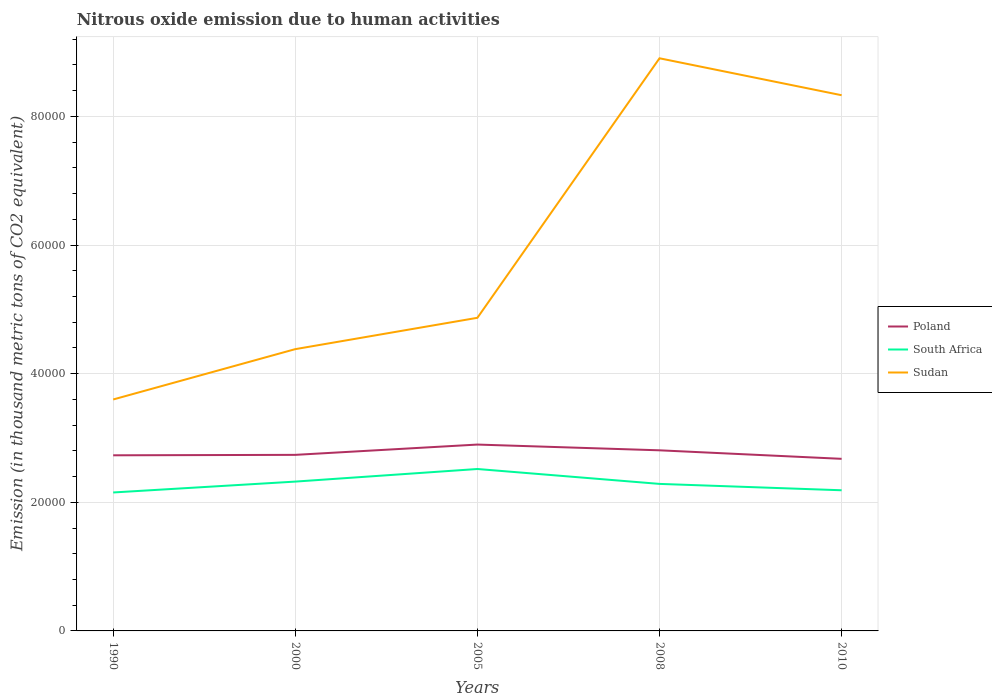Does the line corresponding to Sudan intersect with the line corresponding to South Africa?
Provide a short and direct response. No. Across all years, what is the maximum amount of nitrous oxide emitted in South Africa?
Provide a short and direct response. 2.15e+04. In which year was the amount of nitrous oxide emitted in South Africa maximum?
Keep it short and to the point. 1990. What is the total amount of nitrous oxide emitted in Sudan in the graph?
Your response must be concise. -3.95e+04. What is the difference between the highest and the second highest amount of nitrous oxide emitted in Sudan?
Ensure brevity in your answer.  5.31e+04. Is the amount of nitrous oxide emitted in Sudan strictly greater than the amount of nitrous oxide emitted in South Africa over the years?
Offer a terse response. No. How many years are there in the graph?
Offer a very short reply. 5. Are the values on the major ticks of Y-axis written in scientific E-notation?
Keep it short and to the point. No. Does the graph contain any zero values?
Keep it short and to the point. No. How many legend labels are there?
Your answer should be very brief. 3. How are the legend labels stacked?
Keep it short and to the point. Vertical. What is the title of the graph?
Provide a succinct answer. Nitrous oxide emission due to human activities. Does "Costa Rica" appear as one of the legend labels in the graph?
Provide a short and direct response. No. What is the label or title of the X-axis?
Offer a very short reply. Years. What is the label or title of the Y-axis?
Your answer should be compact. Emission (in thousand metric tons of CO2 equivalent). What is the Emission (in thousand metric tons of CO2 equivalent) in Poland in 1990?
Give a very brief answer. 2.73e+04. What is the Emission (in thousand metric tons of CO2 equivalent) of South Africa in 1990?
Your answer should be compact. 2.15e+04. What is the Emission (in thousand metric tons of CO2 equivalent) of Sudan in 1990?
Provide a succinct answer. 3.60e+04. What is the Emission (in thousand metric tons of CO2 equivalent) of Poland in 2000?
Give a very brief answer. 2.74e+04. What is the Emission (in thousand metric tons of CO2 equivalent) of South Africa in 2000?
Your answer should be compact. 2.32e+04. What is the Emission (in thousand metric tons of CO2 equivalent) in Sudan in 2000?
Keep it short and to the point. 4.38e+04. What is the Emission (in thousand metric tons of CO2 equivalent) of Poland in 2005?
Provide a short and direct response. 2.90e+04. What is the Emission (in thousand metric tons of CO2 equivalent) in South Africa in 2005?
Provide a succinct answer. 2.52e+04. What is the Emission (in thousand metric tons of CO2 equivalent) of Sudan in 2005?
Make the answer very short. 4.87e+04. What is the Emission (in thousand metric tons of CO2 equivalent) of Poland in 2008?
Your answer should be compact. 2.81e+04. What is the Emission (in thousand metric tons of CO2 equivalent) of South Africa in 2008?
Give a very brief answer. 2.29e+04. What is the Emission (in thousand metric tons of CO2 equivalent) of Sudan in 2008?
Ensure brevity in your answer.  8.90e+04. What is the Emission (in thousand metric tons of CO2 equivalent) of Poland in 2010?
Your response must be concise. 2.68e+04. What is the Emission (in thousand metric tons of CO2 equivalent) of South Africa in 2010?
Give a very brief answer. 2.19e+04. What is the Emission (in thousand metric tons of CO2 equivalent) in Sudan in 2010?
Keep it short and to the point. 8.33e+04. Across all years, what is the maximum Emission (in thousand metric tons of CO2 equivalent) of Poland?
Make the answer very short. 2.90e+04. Across all years, what is the maximum Emission (in thousand metric tons of CO2 equivalent) in South Africa?
Provide a succinct answer. 2.52e+04. Across all years, what is the maximum Emission (in thousand metric tons of CO2 equivalent) in Sudan?
Offer a terse response. 8.90e+04. Across all years, what is the minimum Emission (in thousand metric tons of CO2 equivalent) of Poland?
Provide a succinct answer. 2.68e+04. Across all years, what is the minimum Emission (in thousand metric tons of CO2 equivalent) in South Africa?
Give a very brief answer. 2.15e+04. Across all years, what is the minimum Emission (in thousand metric tons of CO2 equivalent) in Sudan?
Offer a very short reply. 3.60e+04. What is the total Emission (in thousand metric tons of CO2 equivalent) in Poland in the graph?
Keep it short and to the point. 1.38e+05. What is the total Emission (in thousand metric tons of CO2 equivalent) of South Africa in the graph?
Offer a terse response. 1.15e+05. What is the total Emission (in thousand metric tons of CO2 equivalent) in Sudan in the graph?
Keep it short and to the point. 3.01e+05. What is the difference between the Emission (in thousand metric tons of CO2 equivalent) in Poland in 1990 and that in 2000?
Provide a short and direct response. -66.8. What is the difference between the Emission (in thousand metric tons of CO2 equivalent) of South Africa in 1990 and that in 2000?
Ensure brevity in your answer.  -1690.3. What is the difference between the Emission (in thousand metric tons of CO2 equivalent) in Sudan in 1990 and that in 2000?
Provide a short and direct response. -7827.3. What is the difference between the Emission (in thousand metric tons of CO2 equivalent) in Poland in 1990 and that in 2005?
Offer a terse response. -1667.4. What is the difference between the Emission (in thousand metric tons of CO2 equivalent) of South Africa in 1990 and that in 2005?
Your answer should be very brief. -3649.4. What is the difference between the Emission (in thousand metric tons of CO2 equivalent) in Sudan in 1990 and that in 2005?
Offer a very short reply. -1.27e+04. What is the difference between the Emission (in thousand metric tons of CO2 equivalent) of Poland in 1990 and that in 2008?
Your answer should be very brief. -773.9. What is the difference between the Emission (in thousand metric tons of CO2 equivalent) in South Africa in 1990 and that in 2008?
Your answer should be compact. -1332.8. What is the difference between the Emission (in thousand metric tons of CO2 equivalent) in Sudan in 1990 and that in 2008?
Your response must be concise. -5.31e+04. What is the difference between the Emission (in thousand metric tons of CO2 equivalent) of Poland in 1990 and that in 2010?
Offer a very short reply. 550.6. What is the difference between the Emission (in thousand metric tons of CO2 equivalent) of South Africa in 1990 and that in 2010?
Your answer should be very brief. -343.1. What is the difference between the Emission (in thousand metric tons of CO2 equivalent) of Sudan in 1990 and that in 2010?
Give a very brief answer. -4.73e+04. What is the difference between the Emission (in thousand metric tons of CO2 equivalent) in Poland in 2000 and that in 2005?
Your answer should be very brief. -1600.6. What is the difference between the Emission (in thousand metric tons of CO2 equivalent) in South Africa in 2000 and that in 2005?
Your response must be concise. -1959.1. What is the difference between the Emission (in thousand metric tons of CO2 equivalent) in Sudan in 2000 and that in 2005?
Offer a very short reply. -4871.9. What is the difference between the Emission (in thousand metric tons of CO2 equivalent) of Poland in 2000 and that in 2008?
Your answer should be very brief. -707.1. What is the difference between the Emission (in thousand metric tons of CO2 equivalent) in South Africa in 2000 and that in 2008?
Provide a short and direct response. 357.5. What is the difference between the Emission (in thousand metric tons of CO2 equivalent) in Sudan in 2000 and that in 2008?
Offer a very short reply. -4.52e+04. What is the difference between the Emission (in thousand metric tons of CO2 equivalent) of Poland in 2000 and that in 2010?
Give a very brief answer. 617.4. What is the difference between the Emission (in thousand metric tons of CO2 equivalent) of South Africa in 2000 and that in 2010?
Provide a succinct answer. 1347.2. What is the difference between the Emission (in thousand metric tons of CO2 equivalent) of Sudan in 2000 and that in 2010?
Offer a terse response. -3.95e+04. What is the difference between the Emission (in thousand metric tons of CO2 equivalent) of Poland in 2005 and that in 2008?
Offer a very short reply. 893.5. What is the difference between the Emission (in thousand metric tons of CO2 equivalent) of South Africa in 2005 and that in 2008?
Provide a succinct answer. 2316.6. What is the difference between the Emission (in thousand metric tons of CO2 equivalent) of Sudan in 2005 and that in 2008?
Provide a short and direct response. -4.04e+04. What is the difference between the Emission (in thousand metric tons of CO2 equivalent) of Poland in 2005 and that in 2010?
Your answer should be very brief. 2218. What is the difference between the Emission (in thousand metric tons of CO2 equivalent) in South Africa in 2005 and that in 2010?
Keep it short and to the point. 3306.3. What is the difference between the Emission (in thousand metric tons of CO2 equivalent) of Sudan in 2005 and that in 2010?
Ensure brevity in your answer.  -3.46e+04. What is the difference between the Emission (in thousand metric tons of CO2 equivalent) in Poland in 2008 and that in 2010?
Offer a terse response. 1324.5. What is the difference between the Emission (in thousand metric tons of CO2 equivalent) in South Africa in 2008 and that in 2010?
Offer a very short reply. 989.7. What is the difference between the Emission (in thousand metric tons of CO2 equivalent) in Sudan in 2008 and that in 2010?
Offer a very short reply. 5743.3. What is the difference between the Emission (in thousand metric tons of CO2 equivalent) of Poland in 1990 and the Emission (in thousand metric tons of CO2 equivalent) of South Africa in 2000?
Make the answer very short. 4090.7. What is the difference between the Emission (in thousand metric tons of CO2 equivalent) of Poland in 1990 and the Emission (in thousand metric tons of CO2 equivalent) of Sudan in 2000?
Offer a very short reply. -1.65e+04. What is the difference between the Emission (in thousand metric tons of CO2 equivalent) in South Africa in 1990 and the Emission (in thousand metric tons of CO2 equivalent) in Sudan in 2000?
Your response must be concise. -2.23e+04. What is the difference between the Emission (in thousand metric tons of CO2 equivalent) in Poland in 1990 and the Emission (in thousand metric tons of CO2 equivalent) in South Africa in 2005?
Offer a terse response. 2131.6. What is the difference between the Emission (in thousand metric tons of CO2 equivalent) in Poland in 1990 and the Emission (in thousand metric tons of CO2 equivalent) in Sudan in 2005?
Your response must be concise. -2.14e+04. What is the difference between the Emission (in thousand metric tons of CO2 equivalent) in South Africa in 1990 and the Emission (in thousand metric tons of CO2 equivalent) in Sudan in 2005?
Ensure brevity in your answer.  -2.72e+04. What is the difference between the Emission (in thousand metric tons of CO2 equivalent) in Poland in 1990 and the Emission (in thousand metric tons of CO2 equivalent) in South Africa in 2008?
Provide a short and direct response. 4448.2. What is the difference between the Emission (in thousand metric tons of CO2 equivalent) in Poland in 1990 and the Emission (in thousand metric tons of CO2 equivalent) in Sudan in 2008?
Provide a succinct answer. -6.17e+04. What is the difference between the Emission (in thousand metric tons of CO2 equivalent) in South Africa in 1990 and the Emission (in thousand metric tons of CO2 equivalent) in Sudan in 2008?
Offer a very short reply. -6.75e+04. What is the difference between the Emission (in thousand metric tons of CO2 equivalent) of Poland in 1990 and the Emission (in thousand metric tons of CO2 equivalent) of South Africa in 2010?
Give a very brief answer. 5437.9. What is the difference between the Emission (in thousand metric tons of CO2 equivalent) in Poland in 1990 and the Emission (in thousand metric tons of CO2 equivalent) in Sudan in 2010?
Ensure brevity in your answer.  -5.60e+04. What is the difference between the Emission (in thousand metric tons of CO2 equivalent) of South Africa in 1990 and the Emission (in thousand metric tons of CO2 equivalent) of Sudan in 2010?
Provide a succinct answer. -6.18e+04. What is the difference between the Emission (in thousand metric tons of CO2 equivalent) of Poland in 2000 and the Emission (in thousand metric tons of CO2 equivalent) of South Africa in 2005?
Offer a very short reply. 2198.4. What is the difference between the Emission (in thousand metric tons of CO2 equivalent) in Poland in 2000 and the Emission (in thousand metric tons of CO2 equivalent) in Sudan in 2005?
Offer a very short reply. -2.13e+04. What is the difference between the Emission (in thousand metric tons of CO2 equivalent) of South Africa in 2000 and the Emission (in thousand metric tons of CO2 equivalent) of Sudan in 2005?
Your response must be concise. -2.55e+04. What is the difference between the Emission (in thousand metric tons of CO2 equivalent) in Poland in 2000 and the Emission (in thousand metric tons of CO2 equivalent) in South Africa in 2008?
Offer a very short reply. 4515. What is the difference between the Emission (in thousand metric tons of CO2 equivalent) of Poland in 2000 and the Emission (in thousand metric tons of CO2 equivalent) of Sudan in 2008?
Offer a terse response. -6.17e+04. What is the difference between the Emission (in thousand metric tons of CO2 equivalent) of South Africa in 2000 and the Emission (in thousand metric tons of CO2 equivalent) of Sudan in 2008?
Offer a terse response. -6.58e+04. What is the difference between the Emission (in thousand metric tons of CO2 equivalent) of Poland in 2000 and the Emission (in thousand metric tons of CO2 equivalent) of South Africa in 2010?
Offer a terse response. 5504.7. What is the difference between the Emission (in thousand metric tons of CO2 equivalent) in Poland in 2000 and the Emission (in thousand metric tons of CO2 equivalent) in Sudan in 2010?
Provide a short and direct response. -5.59e+04. What is the difference between the Emission (in thousand metric tons of CO2 equivalent) in South Africa in 2000 and the Emission (in thousand metric tons of CO2 equivalent) in Sudan in 2010?
Provide a succinct answer. -6.01e+04. What is the difference between the Emission (in thousand metric tons of CO2 equivalent) of Poland in 2005 and the Emission (in thousand metric tons of CO2 equivalent) of South Africa in 2008?
Provide a succinct answer. 6115.6. What is the difference between the Emission (in thousand metric tons of CO2 equivalent) of Poland in 2005 and the Emission (in thousand metric tons of CO2 equivalent) of Sudan in 2008?
Keep it short and to the point. -6.01e+04. What is the difference between the Emission (in thousand metric tons of CO2 equivalent) of South Africa in 2005 and the Emission (in thousand metric tons of CO2 equivalent) of Sudan in 2008?
Provide a succinct answer. -6.39e+04. What is the difference between the Emission (in thousand metric tons of CO2 equivalent) in Poland in 2005 and the Emission (in thousand metric tons of CO2 equivalent) in South Africa in 2010?
Make the answer very short. 7105.3. What is the difference between the Emission (in thousand metric tons of CO2 equivalent) in Poland in 2005 and the Emission (in thousand metric tons of CO2 equivalent) in Sudan in 2010?
Provide a succinct answer. -5.43e+04. What is the difference between the Emission (in thousand metric tons of CO2 equivalent) of South Africa in 2005 and the Emission (in thousand metric tons of CO2 equivalent) of Sudan in 2010?
Make the answer very short. -5.81e+04. What is the difference between the Emission (in thousand metric tons of CO2 equivalent) of Poland in 2008 and the Emission (in thousand metric tons of CO2 equivalent) of South Africa in 2010?
Ensure brevity in your answer.  6211.8. What is the difference between the Emission (in thousand metric tons of CO2 equivalent) of Poland in 2008 and the Emission (in thousand metric tons of CO2 equivalent) of Sudan in 2010?
Ensure brevity in your answer.  -5.52e+04. What is the difference between the Emission (in thousand metric tons of CO2 equivalent) of South Africa in 2008 and the Emission (in thousand metric tons of CO2 equivalent) of Sudan in 2010?
Keep it short and to the point. -6.04e+04. What is the average Emission (in thousand metric tons of CO2 equivalent) in Poland per year?
Provide a succinct answer. 2.77e+04. What is the average Emission (in thousand metric tons of CO2 equivalent) in South Africa per year?
Your response must be concise. 2.29e+04. What is the average Emission (in thousand metric tons of CO2 equivalent) in Sudan per year?
Your answer should be compact. 6.02e+04. In the year 1990, what is the difference between the Emission (in thousand metric tons of CO2 equivalent) of Poland and Emission (in thousand metric tons of CO2 equivalent) of South Africa?
Offer a terse response. 5781. In the year 1990, what is the difference between the Emission (in thousand metric tons of CO2 equivalent) of Poland and Emission (in thousand metric tons of CO2 equivalent) of Sudan?
Keep it short and to the point. -8678. In the year 1990, what is the difference between the Emission (in thousand metric tons of CO2 equivalent) of South Africa and Emission (in thousand metric tons of CO2 equivalent) of Sudan?
Ensure brevity in your answer.  -1.45e+04. In the year 2000, what is the difference between the Emission (in thousand metric tons of CO2 equivalent) of Poland and Emission (in thousand metric tons of CO2 equivalent) of South Africa?
Your answer should be very brief. 4157.5. In the year 2000, what is the difference between the Emission (in thousand metric tons of CO2 equivalent) of Poland and Emission (in thousand metric tons of CO2 equivalent) of Sudan?
Give a very brief answer. -1.64e+04. In the year 2000, what is the difference between the Emission (in thousand metric tons of CO2 equivalent) of South Africa and Emission (in thousand metric tons of CO2 equivalent) of Sudan?
Your answer should be compact. -2.06e+04. In the year 2005, what is the difference between the Emission (in thousand metric tons of CO2 equivalent) in Poland and Emission (in thousand metric tons of CO2 equivalent) in South Africa?
Make the answer very short. 3799. In the year 2005, what is the difference between the Emission (in thousand metric tons of CO2 equivalent) in Poland and Emission (in thousand metric tons of CO2 equivalent) in Sudan?
Give a very brief answer. -1.97e+04. In the year 2005, what is the difference between the Emission (in thousand metric tons of CO2 equivalent) in South Africa and Emission (in thousand metric tons of CO2 equivalent) in Sudan?
Ensure brevity in your answer.  -2.35e+04. In the year 2008, what is the difference between the Emission (in thousand metric tons of CO2 equivalent) of Poland and Emission (in thousand metric tons of CO2 equivalent) of South Africa?
Give a very brief answer. 5222.1. In the year 2008, what is the difference between the Emission (in thousand metric tons of CO2 equivalent) in Poland and Emission (in thousand metric tons of CO2 equivalent) in Sudan?
Your answer should be compact. -6.10e+04. In the year 2008, what is the difference between the Emission (in thousand metric tons of CO2 equivalent) in South Africa and Emission (in thousand metric tons of CO2 equivalent) in Sudan?
Offer a terse response. -6.62e+04. In the year 2010, what is the difference between the Emission (in thousand metric tons of CO2 equivalent) in Poland and Emission (in thousand metric tons of CO2 equivalent) in South Africa?
Give a very brief answer. 4887.3. In the year 2010, what is the difference between the Emission (in thousand metric tons of CO2 equivalent) in Poland and Emission (in thousand metric tons of CO2 equivalent) in Sudan?
Your answer should be compact. -5.65e+04. In the year 2010, what is the difference between the Emission (in thousand metric tons of CO2 equivalent) in South Africa and Emission (in thousand metric tons of CO2 equivalent) in Sudan?
Provide a succinct answer. -6.14e+04. What is the ratio of the Emission (in thousand metric tons of CO2 equivalent) of South Africa in 1990 to that in 2000?
Give a very brief answer. 0.93. What is the ratio of the Emission (in thousand metric tons of CO2 equivalent) of Sudan in 1990 to that in 2000?
Provide a short and direct response. 0.82. What is the ratio of the Emission (in thousand metric tons of CO2 equivalent) of Poland in 1990 to that in 2005?
Keep it short and to the point. 0.94. What is the ratio of the Emission (in thousand metric tons of CO2 equivalent) of South Africa in 1990 to that in 2005?
Make the answer very short. 0.85. What is the ratio of the Emission (in thousand metric tons of CO2 equivalent) of Sudan in 1990 to that in 2005?
Offer a terse response. 0.74. What is the ratio of the Emission (in thousand metric tons of CO2 equivalent) of Poland in 1990 to that in 2008?
Provide a short and direct response. 0.97. What is the ratio of the Emission (in thousand metric tons of CO2 equivalent) in South Africa in 1990 to that in 2008?
Your response must be concise. 0.94. What is the ratio of the Emission (in thousand metric tons of CO2 equivalent) in Sudan in 1990 to that in 2008?
Provide a short and direct response. 0.4. What is the ratio of the Emission (in thousand metric tons of CO2 equivalent) of Poland in 1990 to that in 2010?
Offer a terse response. 1.02. What is the ratio of the Emission (in thousand metric tons of CO2 equivalent) in South Africa in 1990 to that in 2010?
Offer a very short reply. 0.98. What is the ratio of the Emission (in thousand metric tons of CO2 equivalent) of Sudan in 1990 to that in 2010?
Your answer should be very brief. 0.43. What is the ratio of the Emission (in thousand metric tons of CO2 equivalent) in Poland in 2000 to that in 2005?
Make the answer very short. 0.94. What is the ratio of the Emission (in thousand metric tons of CO2 equivalent) in South Africa in 2000 to that in 2005?
Your answer should be very brief. 0.92. What is the ratio of the Emission (in thousand metric tons of CO2 equivalent) of Sudan in 2000 to that in 2005?
Offer a very short reply. 0.9. What is the ratio of the Emission (in thousand metric tons of CO2 equivalent) of Poland in 2000 to that in 2008?
Provide a short and direct response. 0.97. What is the ratio of the Emission (in thousand metric tons of CO2 equivalent) in South Africa in 2000 to that in 2008?
Your response must be concise. 1.02. What is the ratio of the Emission (in thousand metric tons of CO2 equivalent) of Sudan in 2000 to that in 2008?
Provide a succinct answer. 0.49. What is the ratio of the Emission (in thousand metric tons of CO2 equivalent) of Poland in 2000 to that in 2010?
Keep it short and to the point. 1.02. What is the ratio of the Emission (in thousand metric tons of CO2 equivalent) in South Africa in 2000 to that in 2010?
Provide a short and direct response. 1.06. What is the ratio of the Emission (in thousand metric tons of CO2 equivalent) of Sudan in 2000 to that in 2010?
Give a very brief answer. 0.53. What is the ratio of the Emission (in thousand metric tons of CO2 equivalent) of Poland in 2005 to that in 2008?
Offer a very short reply. 1.03. What is the ratio of the Emission (in thousand metric tons of CO2 equivalent) of South Africa in 2005 to that in 2008?
Provide a succinct answer. 1.1. What is the ratio of the Emission (in thousand metric tons of CO2 equivalent) of Sudan in 2005 to that in 2008?
Keep it short and to the point. 0.55. What is the ratio of the Emission (in thousand metric tons of CO2 equivalent) of Poland in 2005 to that in 2010?
Offer a terse response. 1.08. What is the ratio of the Emission (in thousand metric tons of CO2 equivalent) of South Africa in 2005 to that in 2010?
Make the answer very short. 1.15. What is the ratio of the Emission (in thousand metric tons of CO2 equivalent) in Sudan in 2005 to that in 2010?
Make the answer very short. 0.58. What is the ratio of the Emission (in thousand metric tons of CO2 equivalent) in Poland in 2008 to that in 2010?
Keep it short and to the point. 1.05. What is the ratio of the Emission (in thousand metric tons of CO2 equivalent) of South Africa in 2008 to that in 2010?
Give a very brief answer. 1.05. What is the ratio of the Emission (in thousand metric tons of CO2 equivalent) of Sudan in 2008 to that in 2010?
Ensure brevity in your answer.  1.07. What is the difference between the highest and the second highest Emission (in thousand metric tons of CO2 equivalent) of Poland?
Your response must be concise. 893.5. What is the difference between the highest and the second highest Emission (in thousand metric tons of CO2 equivalent) of South Africa?
Your answer should be very brief. 1959.1. What is the difference between the highest and the second highest Emission (in thousand metric tons of CO2 equivalent) in Sudan?
Your answer should be compact. 5743.3. What is the difference between the highest and the lowest Emission (in thousand metric tons of CO2 equivalent) in Poland?
Provide a short and direct response. 2218. What is the difference between the highest and the lowest Emission (in thousand metric tons of CO2 equivalent) in South Africa?
Your answer should be compact. 3649.4. What is the difference between the highest and the lowest Emission (in thousand metric tons of CO2 equivalent) of Sudan?
Offer a terse response. 5.31e+04. 